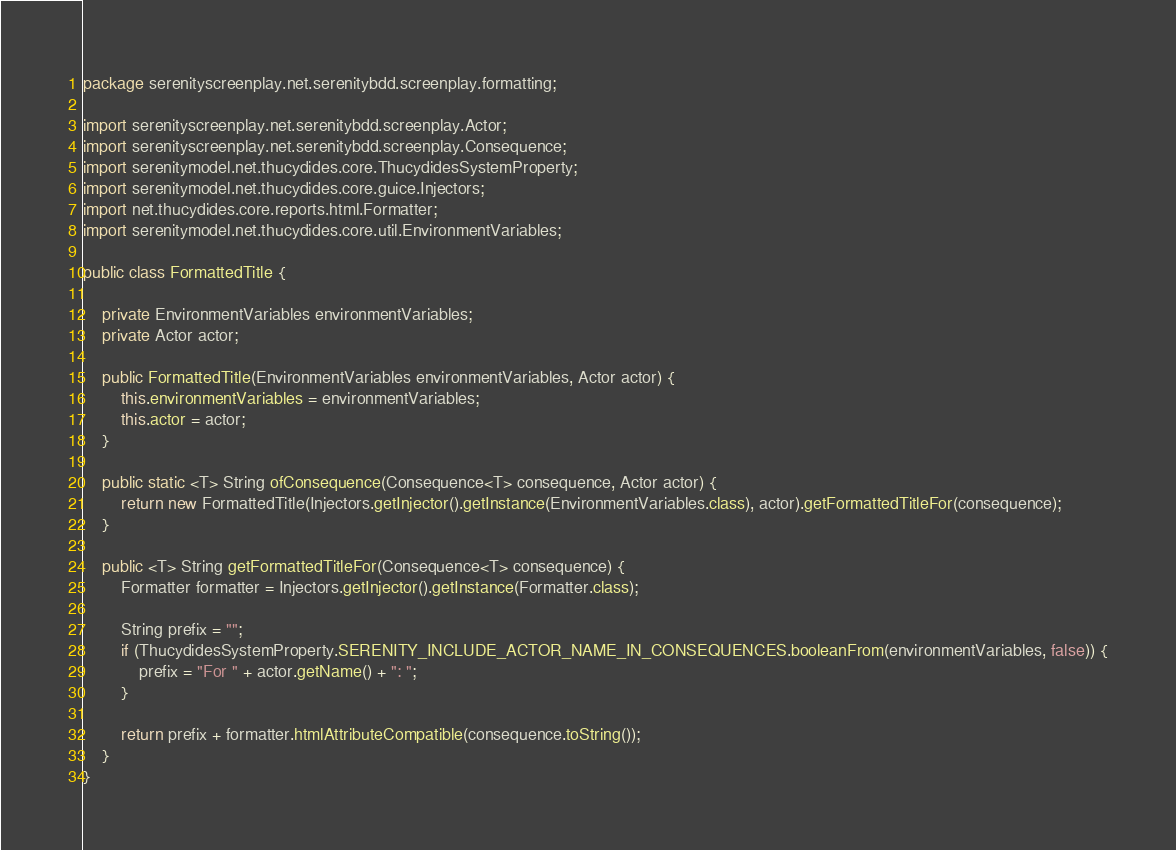<code> <loc_0><loc_0><loc_500><loc_500><_Java_>package serenityscreenplay.net.serenitybdd.screenplay.formatting;

import serenityscreenplay.net.serenitybdd.screenplay.Actor;
import serenityscreenplay.net.serenitybdd.screenplay.Consequence;
import serenitymodel.net.thucydides.core.ThucydidesSystemProperty;
import serenitymodel.net.thucydides.core.guice.Injectors;
import net.thucydides.core.reports.html.Formatter;
import serenitymodel.net.thucydides.core.util.EnvironmentVariables;

public class FormattedTitle {

    private EnvironmentVariables environmentVariables;
    private Actor actor;

    public FormattedTitle(EnvironmentVariables environmentVariables, Actor actor) {
        this.environmentVariables = environmentVariables;
        this.actor = actor;
    }

    public static <T> String ofConsequence(Consequence<T> consequence, Actor actor) {
        return new FormattedTitle(Injectors.getInjector().getInstance(EnvironmentVariables.class), actor).getFormattedTitleFor(consequence);
    }

    public <T> String getFormattedTitleFor(Consequence<T> consequence) {
        Formatter formatter = Injectors.getInjector().getInstance(Formatter.class);

        String prefix = "";
        if (ThucydidesSystemProperty.SERENITY_INCLUDE_ACTOR_NAME_IN_CONSEQUENCES.booleanFrom(environmentVariables, false)) {
            prefix = "For " + actor.getName() + ": ";
        }

        return prefix + formatter.htmlAttributeCompatible(consequence.toString());
    }
}
</code> 